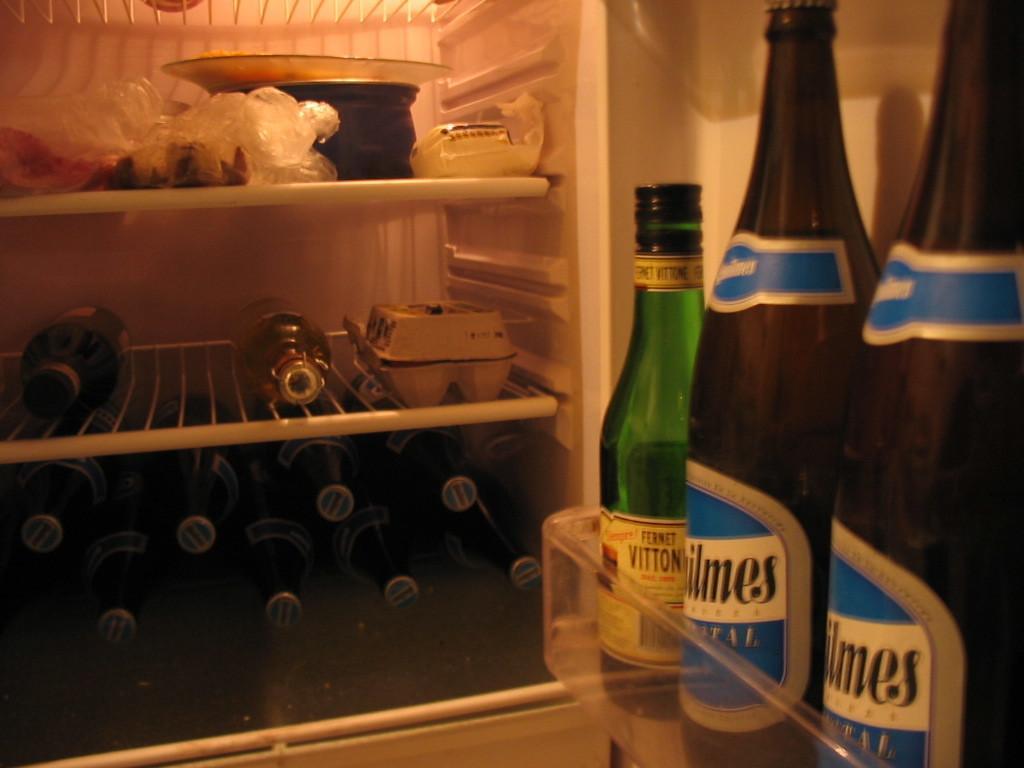In one or two sentences, can you explain what this image depicts? In this image, there is a inside view of fridge, in which bottles are kept, bowls are kept and egg tray is kept. This image is taken inside the room and inside the fridge. 